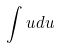Convert formula to latex. <formula><loc_0><loc_0><loc_500><loc_500>\int u d u</formula> 